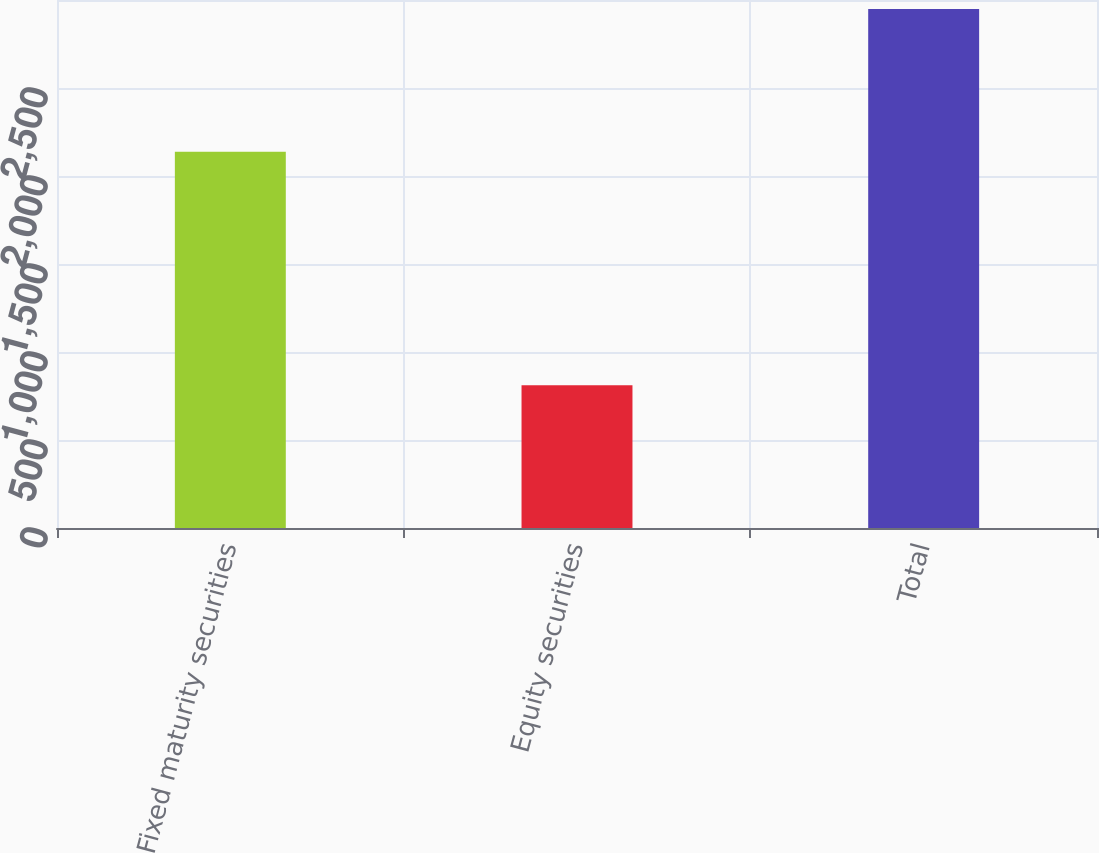Convert chart to OTSL. <chart><loc_0><loc_0><loc_500><loc_500><bar_chart><fcel>Fixed maturity securities<fcel>Equity securities<fcel>Total<nl><fcel>2138<fcel>811<fcel>2949<nl></chart> 